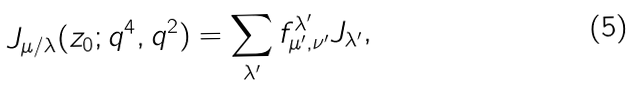<formula> <loc_0><loc_0><loc_500><loc_500>J _ { \mu / \lambda } ( z _ { 0 } ; q ^ { 4 } , q ^ { 2 } ) = \sum _ { \lambda ^ { \prime } } f _ { \mu ^ { \prime } , \nu ^ { \prime } } ^ { \lambda ^ { \prime } } J _ { \lambda ^ { \prime } } ,</formula> 